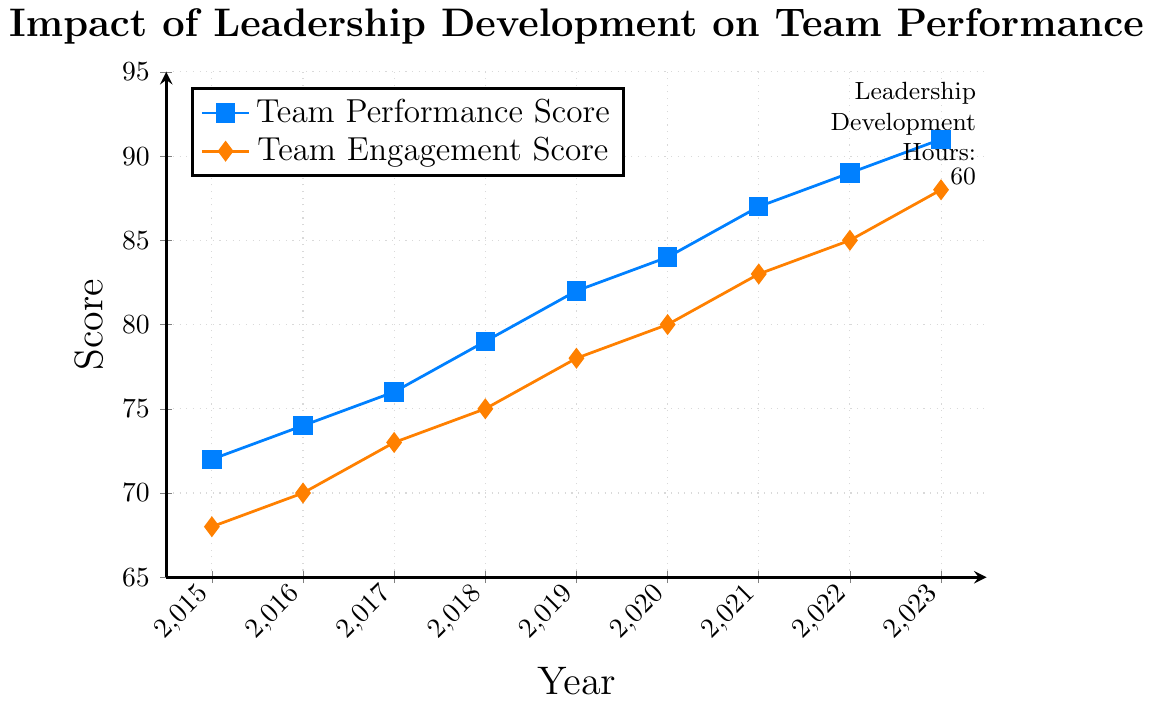Which year saw the highest Team Performance Score? By examining the line labeled "Team Performance Score", we can see that the highest point on the graph is in 2023.
Answer: 2023 Which was higher in 2018, the Team Performance Score or the Team Engagement Score? For the year 2018, we compare the points on both lines. The Team Performance Score is 79, whereas the Team Engagement Score is 75.
Answer: Team Performance Score What is the difference between the Team Performance Score and Team Engagement Score in 2020? In 2020, the Team Performance Score is 84 and the Team Engagement Score is 80. The difference is 84 - 80.
Answer: 4 How much did the Team Engagement Score change from 2016 to 2017? The Team Engagement Score in 2016 is 70 and in 2017, it is 73. The change is 73 - 70.
Answer: 3 In which year did the Team Engagement Score first reach 80? Trace the "Team Engagement Score" line to see where it first hits 80. This occurs in the year 2020.
Answer: 2020 By how many points did the Team Performance Score increase from 2015 to 2023? The Team Performance Score in 2015 is 72 and 91 in 2023. The increase is calculated as 91 - 72.
Answer: 19 In what year were both the Team Performance Score and Team Engagement Score compared the closest? To find where the scores are closest to each other, compare the gaps in each year. The smallest difference is 4 in 2020 (84 - 80).
Answer: 2020 What is the average Team Performance Score for the years 2015 to 2023? Add all the Team Performance Scores from 2015 (72) to 2023 (91) and divide by the number of years (9). The sum is 720, so the average is 720 / 9.
Answer: 80 Which line color represents the Team Engagement Score? Based on the legend, the line representing the Team Engagement Score is colored orange.
Answer: Orange What can you infer about the trend of both scores over the years? Both lines show a steady increase from 2015 to 2023, indicating continuous improvement in Team Performance and Engagement Scores over the years.
Answer: Continuous improvement 